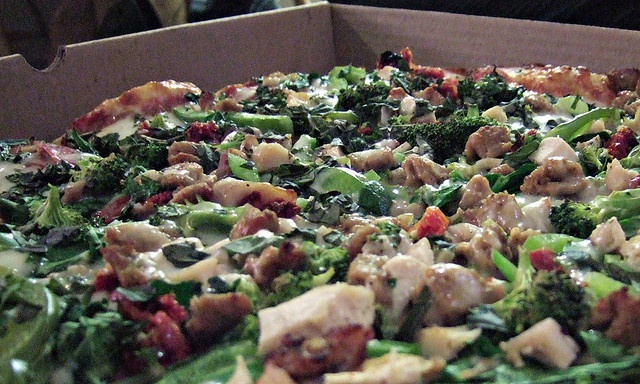Describe the objects in this image and their specific colors. I can see pizza in black, gray, tan, and darkgray tones, broccoli in black, gray, and darkgreen tones, broccoli in black, darkgreen, and olive tones, broccoli in black, gray, olive, and darkgray tones, and broccoli in black, olive, and darkgreen tones in this image. 